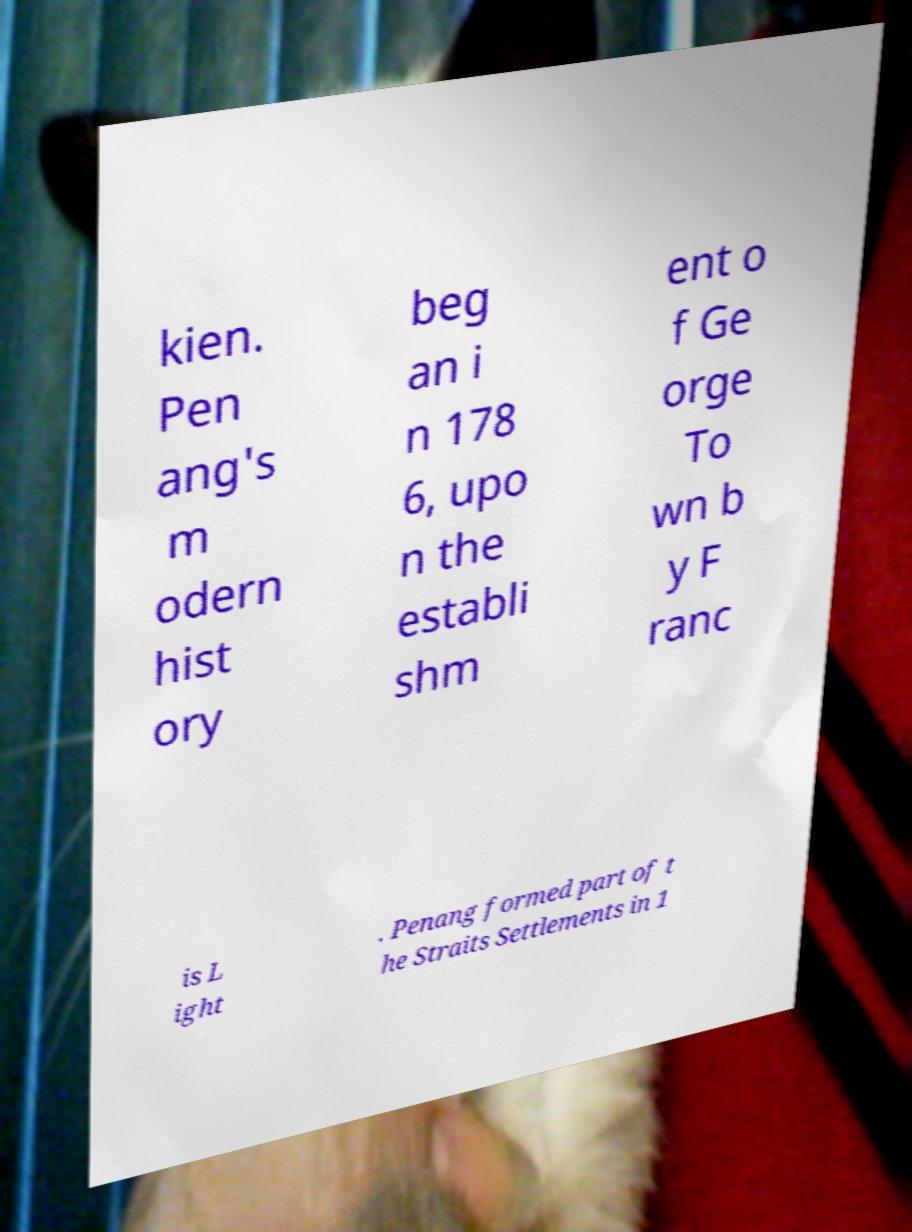There's text embedded in this image that I need extracted. Can you transcribe it verbatim? kien. Pen ang's m odern hist ory beg an i n 178 6, upo n the establi shm ent o f Ge orge To wn b y F ranc is L ight . Penang formed part of t he Straits Settlements in 1 